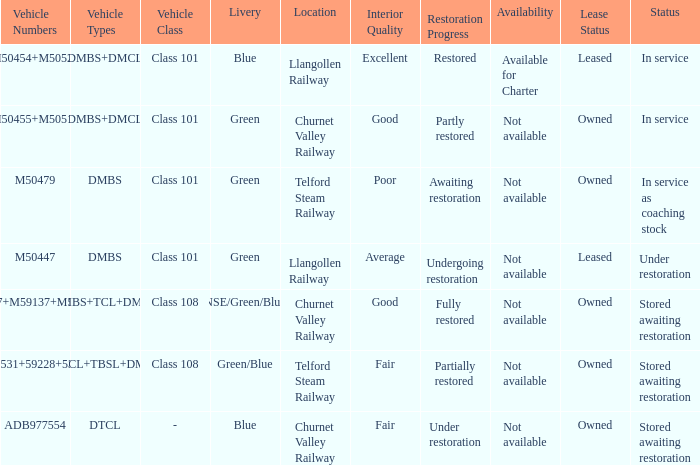What livery has a status of in service as coaching stock? Green. 